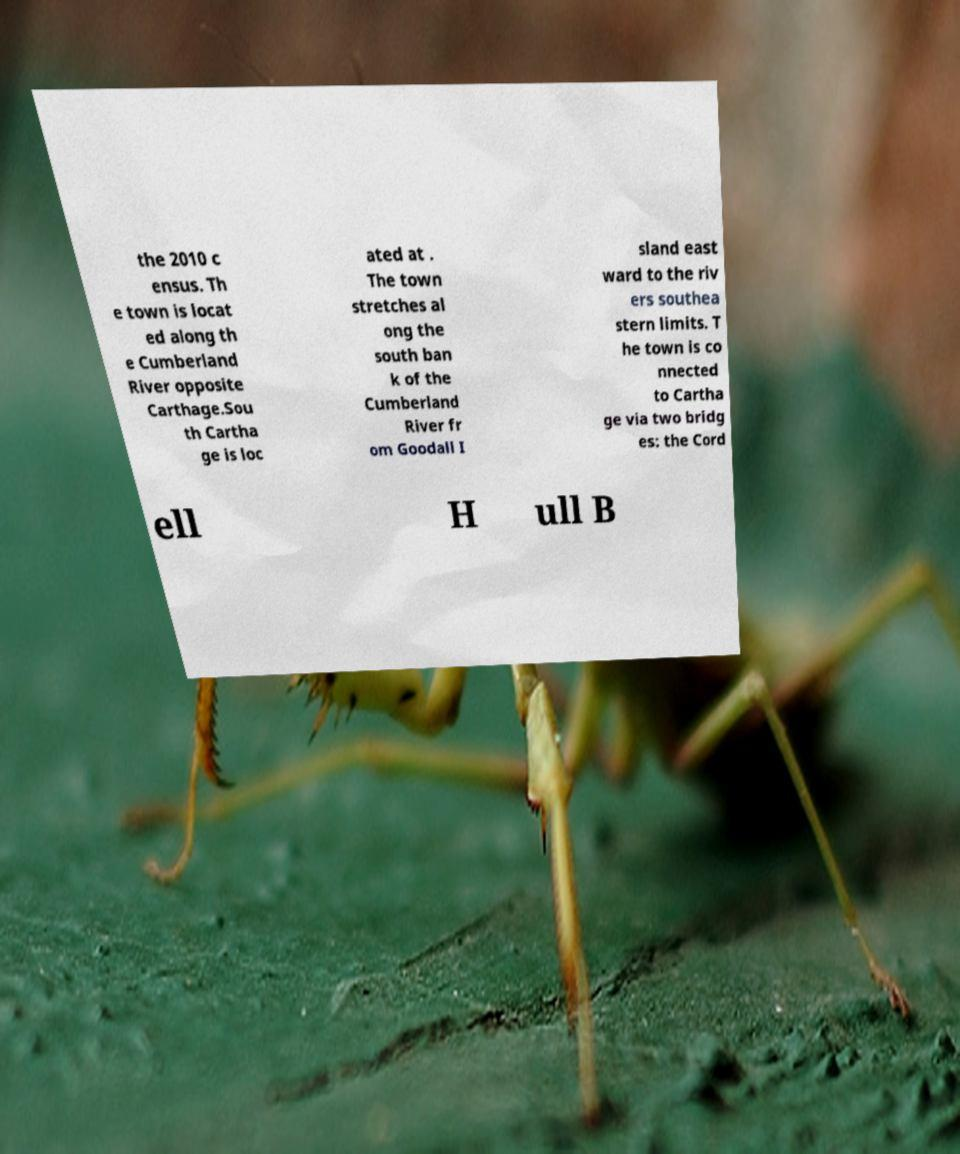What messages or text are displayed in this image? I need them in a readable, typed format. the 2010 c ensus. Th e town is locat ed along th e Cumberland River opposite Carthage.Sou th Cartha ge is loc ated at . The town stretches al ong the south ban k of the Cumberland River fr om Goodall I sland east ward to the riv ers southea stern limits. T he town is co nnected to Cartha ge via two bridg es: the Cord ell H ull B 